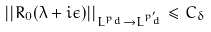<formula> <loc_0><loc_0><loc_500><loc_500>| | R _ { 0 } ( \lambda + i \epsilon ) | | _ { L ^ { p _ { d } } \to L ^ { p ^ { \prime } _ { d } } } \leq C _ { \delta }</formula> 